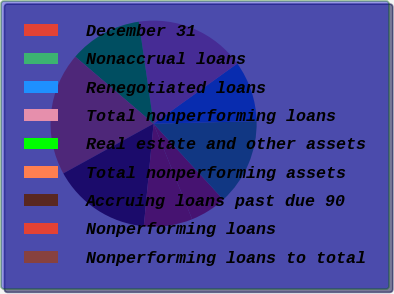<chart> <loc_0><loc_0><loc_500><loc_500><pie_chart><fcel>December 31<fcel>Nonaccrual loans<fcel>Renegotiated loans<fcel>Total nonperforming loans<fcel>Real estate and other assets<fcel>Total nonperforming assets<fcel>Accruing loans past due 90<fcel>Nonperforming loans<fcel>Nonperforming loans to total<nl><fcel>5.72%<fcel>13.56%<fcel>9.53%<fcel>17.38%<fcel>11.44%<fcel>19.28%<fcel>15.47%<fcel>7.62%<fcel>0.0%<nl></chart> 